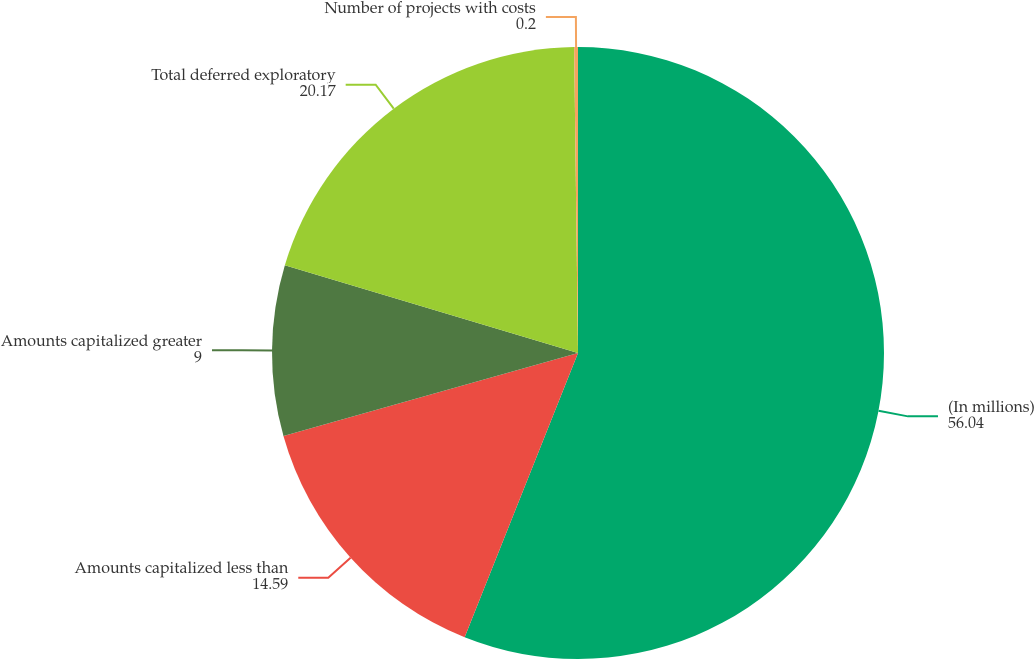Convert chart. <chart><loc_0><loc_0><loc_500><loc_500><pie_chart><fcel>(In millions)<fcel>Amounts capitalized less than<fcel>Amounts capitalized greater<fcel>Total deferred exploratory<fcel>Number of projects with costs<nl><fcel>56.04%<fcel>14.59%<fcel>9.0%<fcel>20.17%<fcel>0.2%<nl></chart> 